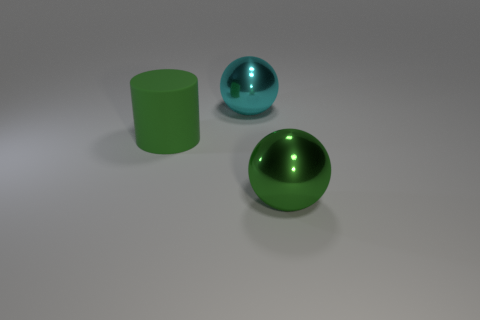There is a shiny ball that is behind the big green rubber object; how big is it?
Give a very brief answer. Large. Are there any other balls of the same size as the green metal ball?
Offer a very short reply. Yes. There is a green object that is behind the green metallic thing; is its size the same as the green sphere?
Make the answer very short. Yes. How big is the green metal thing?
Ensure brevity in your answer.  Large. What is the color of the large metallic ball that is in front of the big metallic ball that is on the left side of the metallic ball in front of the big cyan metallic object?
Provide a succinct answer. Green. Is the color of the ball behind the green shiny object the same as the matte cylinder?
Provide a short and direct response. No. What number of objects are both in front of the big cyan thing and to the right of the matte object?
Keep it short and to the point. 1. What is the size of the green shiny object that is the same shape as the big cyan shiny object?
Offer a very short reply. Large. What number of big balls are behind the big green object that is behind the big ball in front of the matte object?
Your response must be concise. 1. What is the color of the big metallic sphere that is behind the green object that is right of the cyan sphere?
Provide a short and direct response. Cyan. 